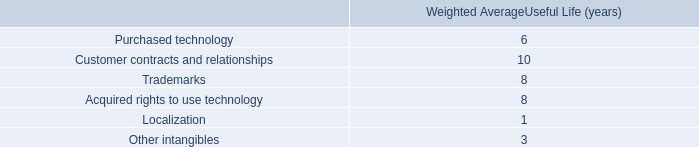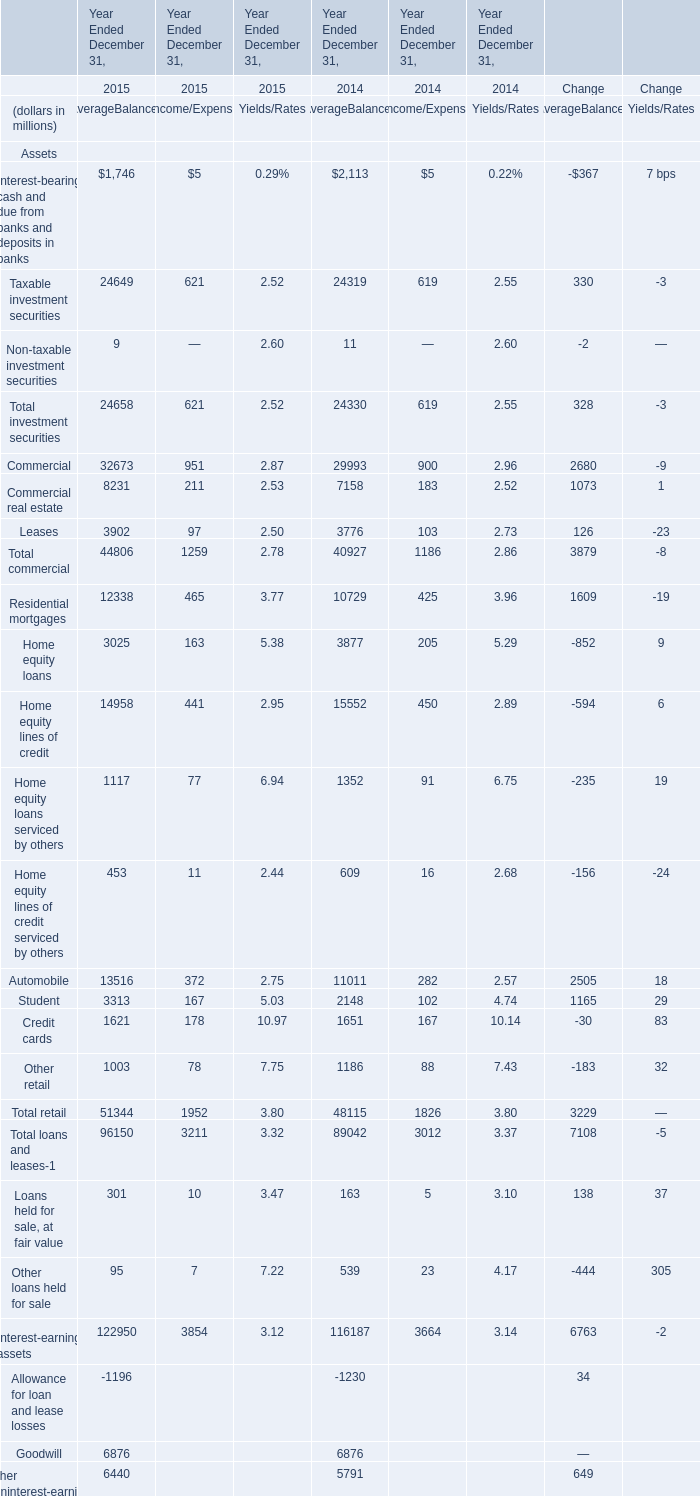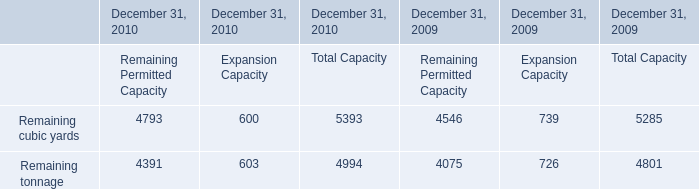Which year is Taxable investment securities the highest for AverageBalances ? 
Answer: 2015. What is the average amount of Residential mortgages of Year Ended December 31, 2014 AverageBalances, and Remaining cubic yards of December 31, 2009 Remaining Permitted Capacity ? 
Computations: ((10729.0 + 4546.0) / 2)
Answer: 7637.5. 